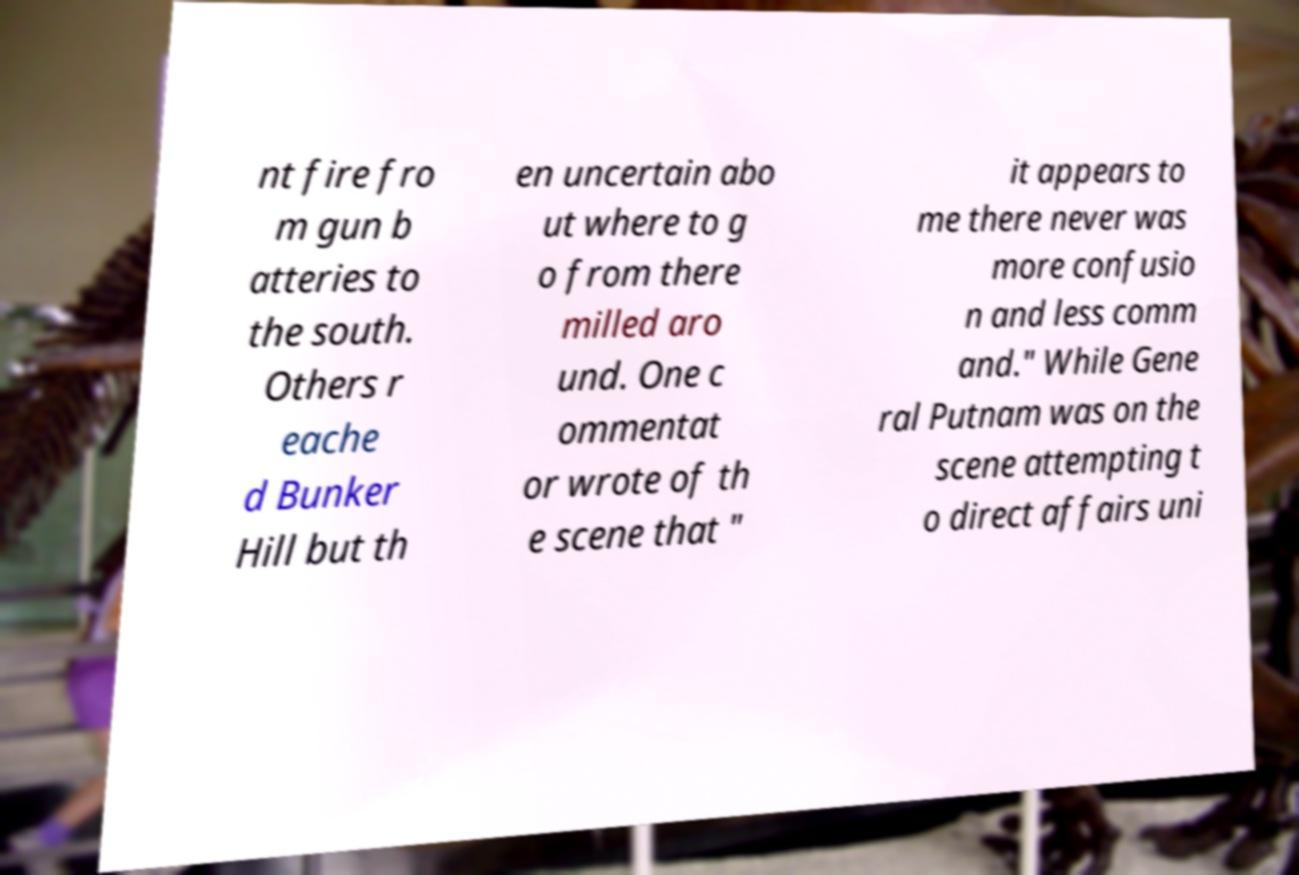Please read and relay the text visible in this image. What does it say? nt fire fro m gun b atteries to the south. Others r eache d Bunker Hill but th en uncertain abo ut where to g o from there milled aro und. One c ommentat or wrote of th e scene that " it appears to me there never was more confusio n and less comm and." While Gene ral Putnam was on the scene attempting t o direct affairs uni 